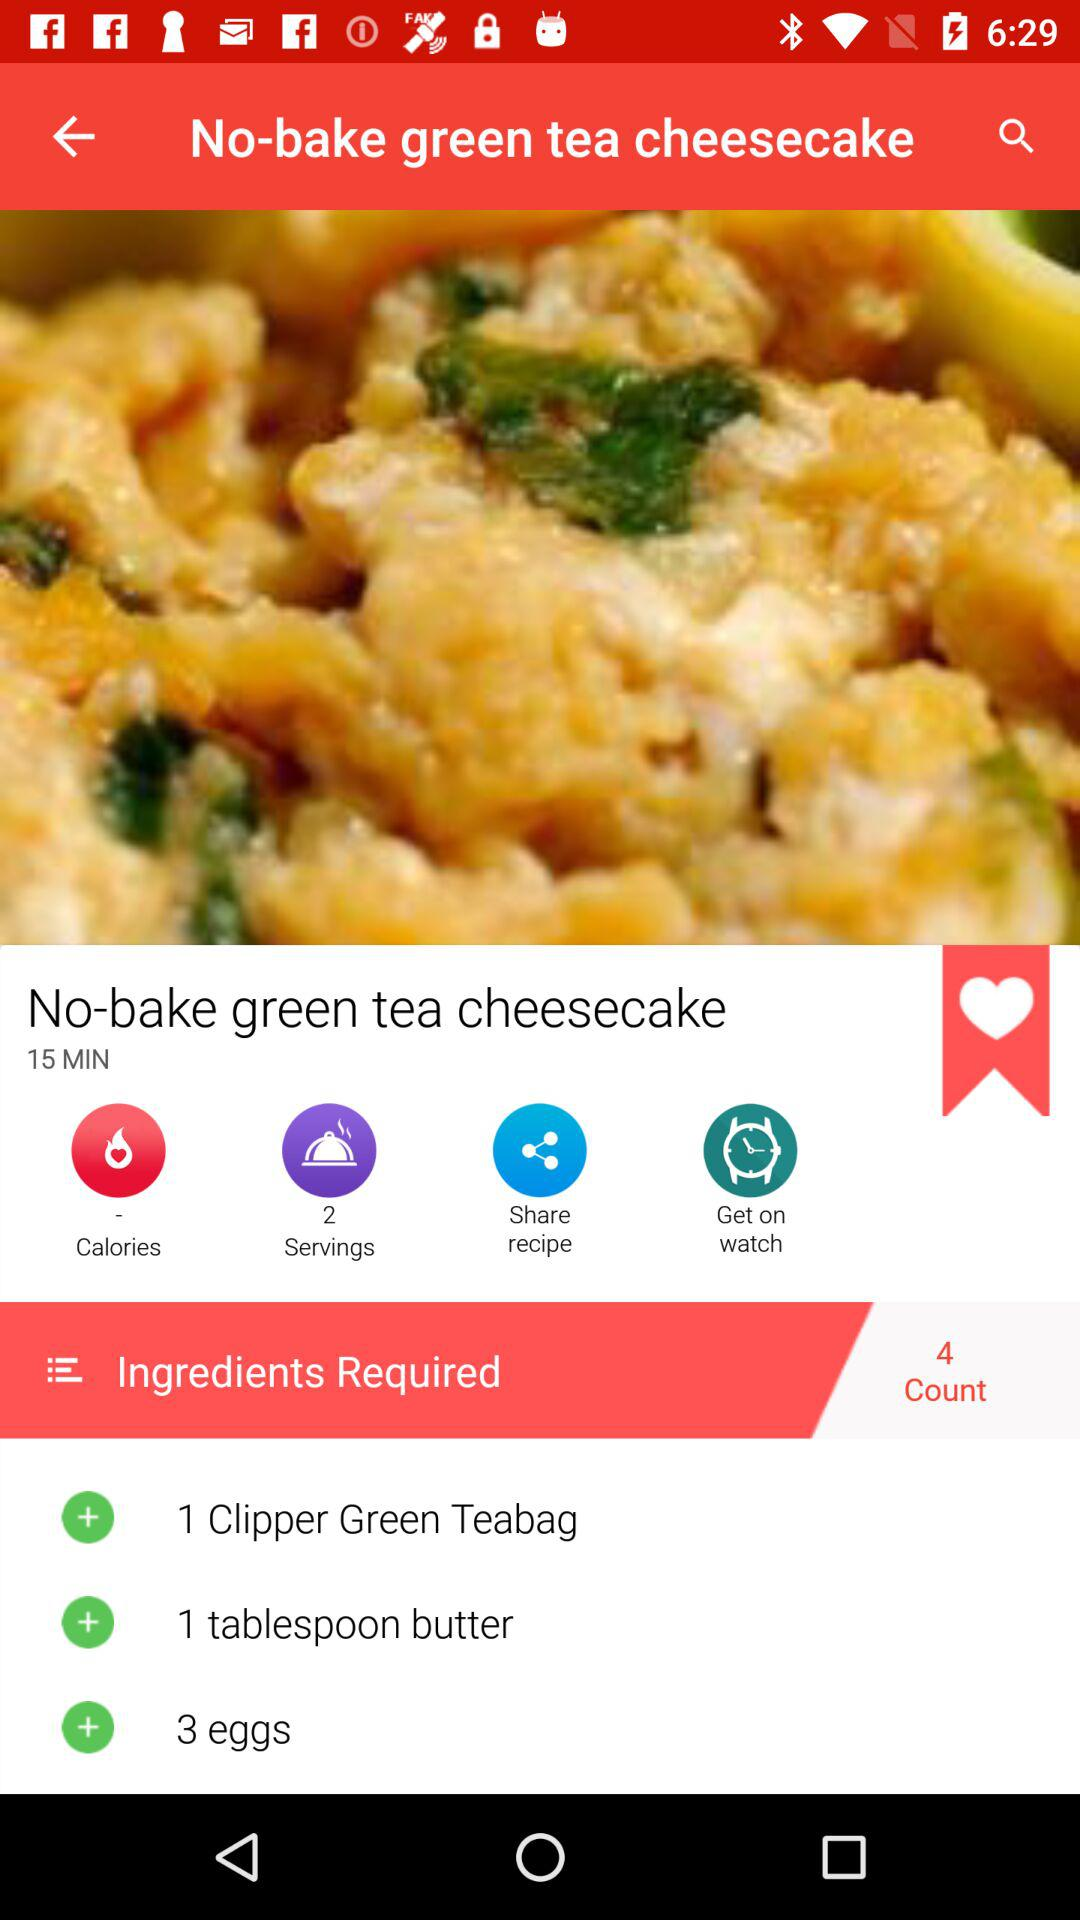How many servings does this recipe make?
Answer the question using a single word or phrase. 2 